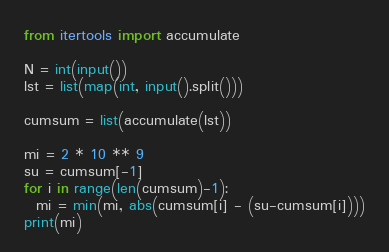<code> <loc_0><loc_0><loc_500><loc_500><_Python_>from itertools import accumulate

N = int(input())
lst = list(map(int, input().split()))

cumsum = list(accumulate(lst))

mi = 2 * 10 ** 9
su = cumsum[-1]
for i in range(len(cumsum)-1):
  mi = min(mi, abs(cumsum[i] - (su-cumsum[i])))
print(mi)</code> 